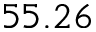<formula> <loc_0><loc_0><loc_500><loc_500>5 5 . 2 6</formula> 